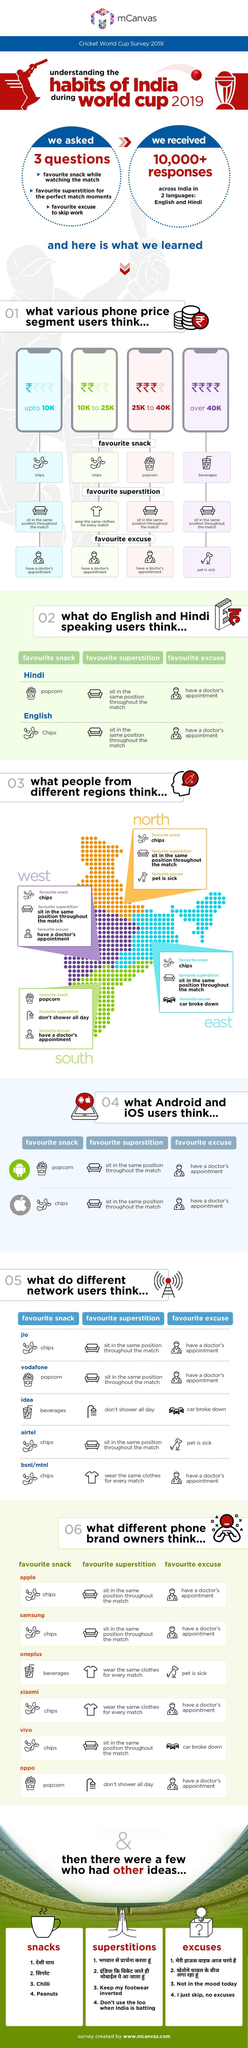How many phone brand owners have the same answer "wear the same clothes for every match" for the question "favorite superstition"?
Answer the question with a short phrase. 2 What is the favorite snack of phone users of up to 10k price? chips How many regions have chips as the favorite snack? 3 How many answers are the same for android and IOS users? 2 What is the favorite excuse of phone users of price 10k to 25k? have a doctor's appointment How many answers are the same for Hindi and English speaking users? 2 Which all network users have chips as the favorite snack? jio, airtel, bsnl/mtnl What is the favorite snack of phone users of price 25k to 40k? popcorn 